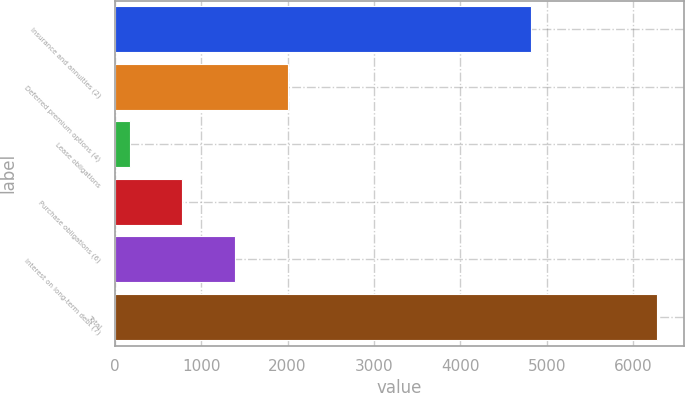Convert chart. <chart><loc_0><loc_0><loc_500><loc_500><bar_chart><fcel>Insurance and annuities (2)<fcel>Deferred premium options (4)<fcel>Lease obligations<fcel>Purchase obligations (6)<fcel>Interest on long-term debt (7)<fcel>Total<nl><fcel>4815<fcel>2003.1<fcel>171<fcel>781.7<fcel>1392.4<fcel>6278<nl></chart> 